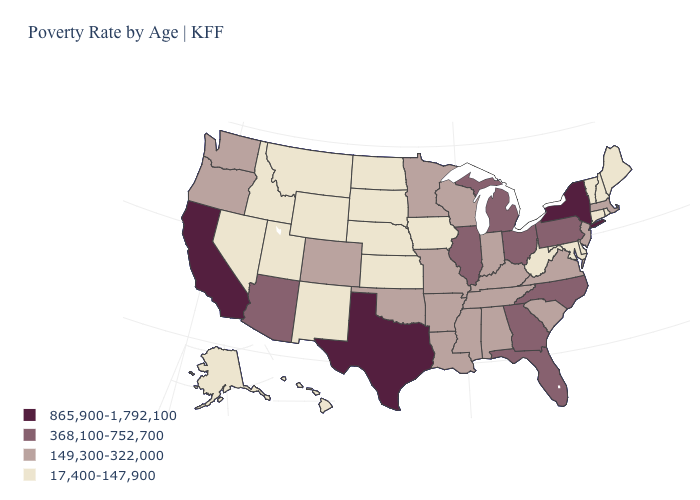Name the states that have a value in the range 149,300-322,000?
Be succinct. Alabama, Arkansas, Colorado, Indiana, Kentucky, Louisiana, Massachusetts, Minnesota, Mississippi, Missouri, New Jersey, Oklahoma, Oregon, South Carolina, Tennessee, Virginia, Washington, Wisconsin. Name the states that have a value in the range 17,400-147,900?
Answer briefly. Alaska, Connecticut, Delaware, Hawaii, Idaho, Iowa, Kansas, Maine, Maryland, Montana, Nebraska, Nevada, New Hampshire, New Mexico, North Dakota, Rhode Island, South Dakota, Utah, Vermont, West Virginia, Wyoming. Does the map have missing data?
Short answer required. No. Which states hav the highest value in the West?
Concise answer only. California. Name the states that have a value in the range 865,900-1,792,100?
Short answer required. California, New York, Texas. Does Nebraska have the same value as Vermont?
Quick response, please. Yes. What is the value of Michigan?
Give a very brief answer. 368,100-752,700. What is the value of Pennsylvania?
Write a very short answer. 368,100-752,700. What is the lowest value in states that border Utah?
Give a very brief answer. 17,400-147,900. Which states have the lowest value in the South?
Concise answer only. Delaware, Maryland, West Virginia. What is the value of Maine?
Quick response, please. 17,400-147,900. Which states have the lowest value in the South?
Give a very brief answer. Delaware, Maryland, West Virginia. Name the states that have a value in the range 149,300-322,000?
Be succinct. Alabama, Arkansas, Colorado, Indiana, Kentucky, Louisiana, Massachusetts, Minnesota, Mississippi, Missouri, New Jersey, Oklahoma, Oregon, South Carolina, Tennessee, Virginia, Washington, Wisconsin. Which states hav the highest value in the Northeast?
Concise answer only. New York. Name the states that have a value in the range 149,300-322,000?
Be succinct. Alabama, Arkansas, Colorado, Indiana, Kentucky, Louisiana, Massachusetts, Minnesota, Mississippi, Missouri, New Jersey, Oklahoma, Oregon, South Carolina, Tennessee, Virginia, Washington, Wisconsin. 